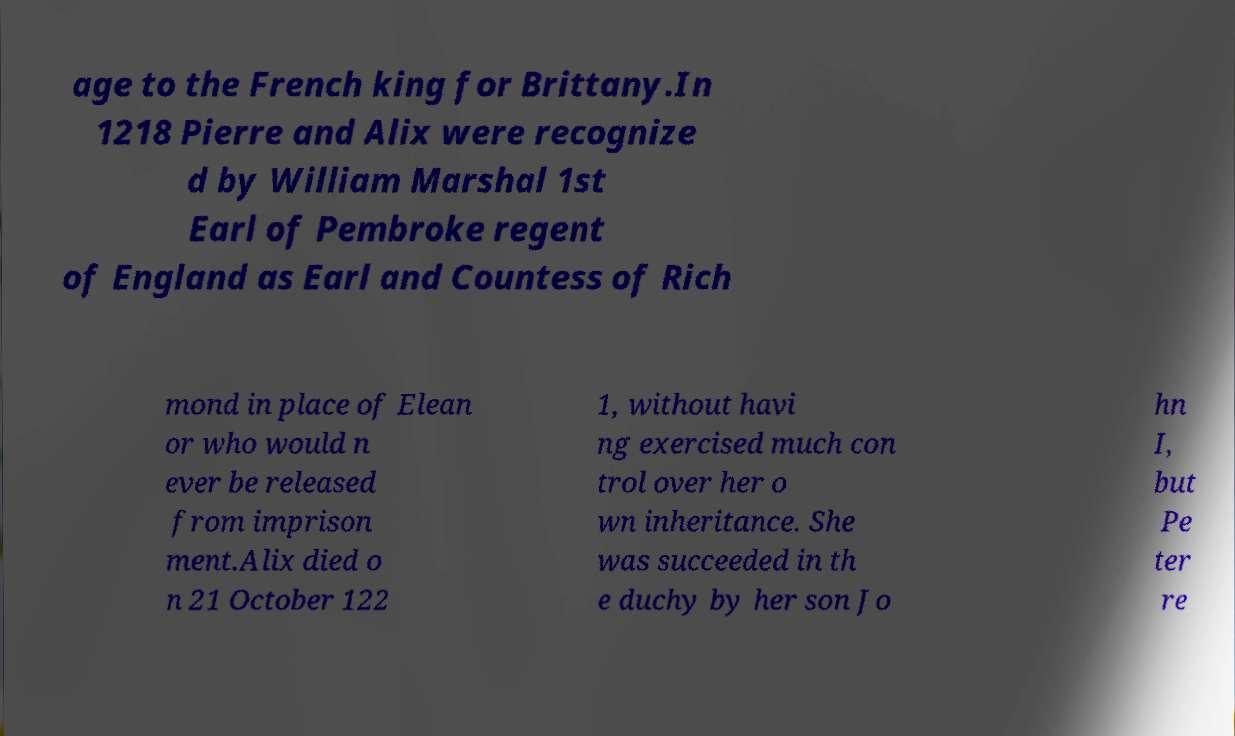Please identify and transcribe the text found in this image. age to the French king for Brittany.In 1218 Pierre and Alix were recognize d by William Marshal 1st Earl of Pembroke regent of England as Earl and Countess of Rich mond in place of Elean or who would n ever be released from imprison ment.Alix died o n 21 October 122 1, without havi ng exercised much con trol over her o wn inheritance. She was succeeded in th e duchy by her son Jo hn I, but Pe ter re 